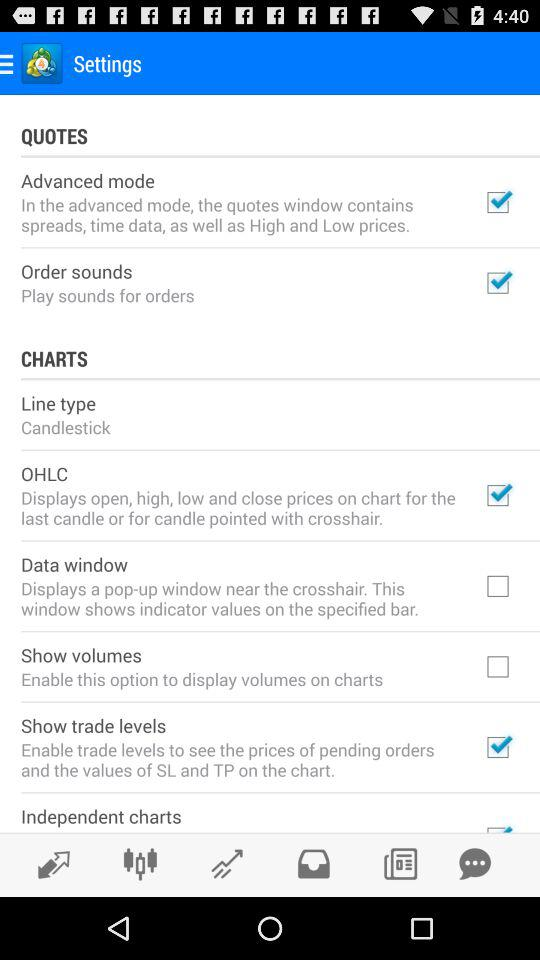What is the status of "Advanced mode"? The status is on. 